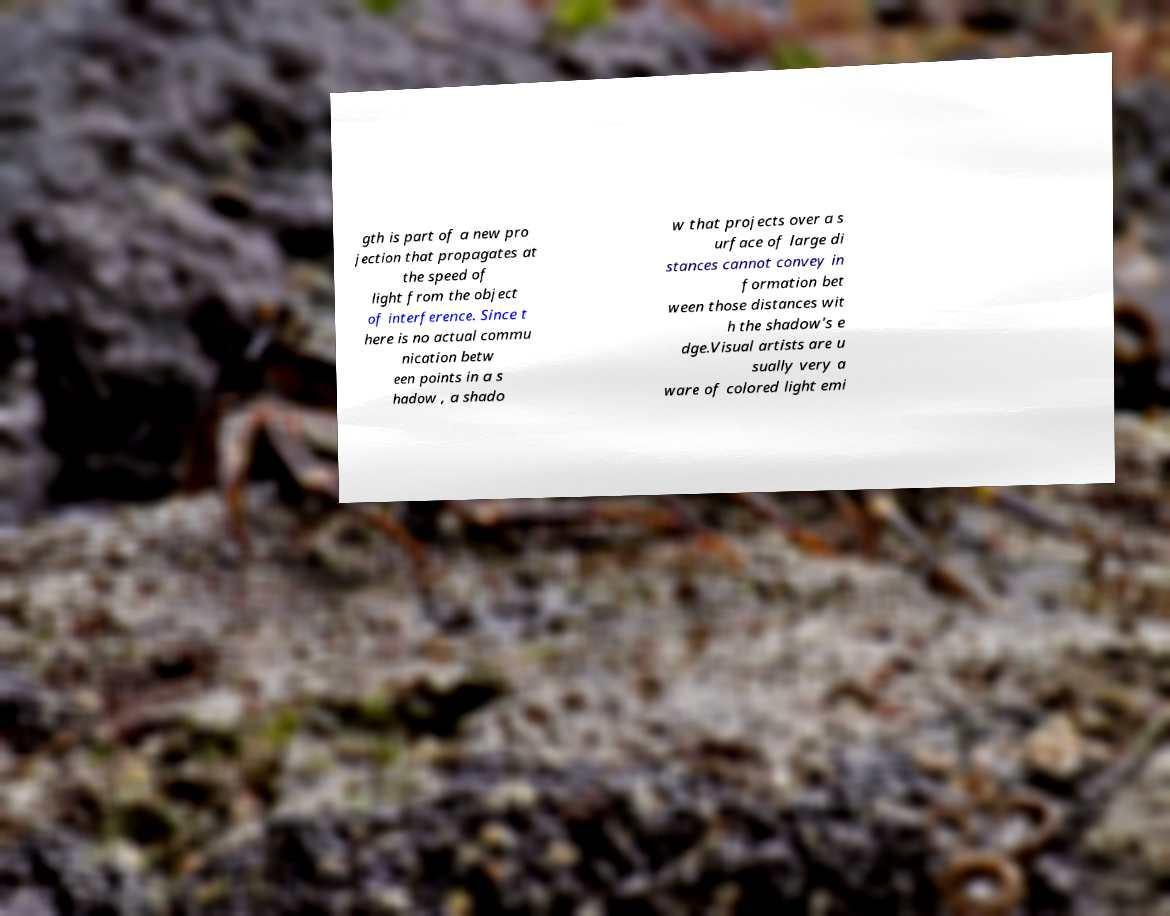Can you accurately transcribe the text from the provided image for me? gth is part of a new pro jection that propagates at the speed of light from the object of interference. Since t here is no actual commu nication betw een points in a s hadow , a shado w that projects over a s urface of large di stances cannot convey in formation bet ween those distances wit h the shadow's e dge.Visual artists are u sually very a ware of colored light emi 